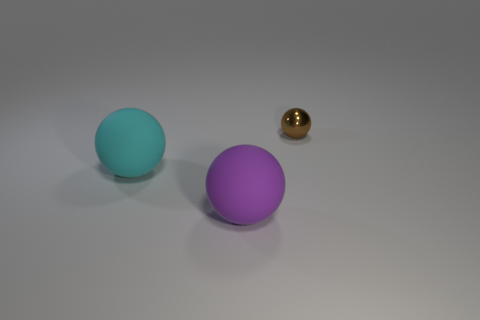Add 1 tiny yellow metallic objects. How many objects exist? 4 Subtract all green matte cylinders. Subtract all purple things. How many objects are left? 2 Add 3 purple matte objects. How many purple matte objects are left? 4 Add 1 large cyan metallic cubes. How many large cyan metallic cubes exist? 1 Subtract 0 purple cylinders. How many objects are left? 3 